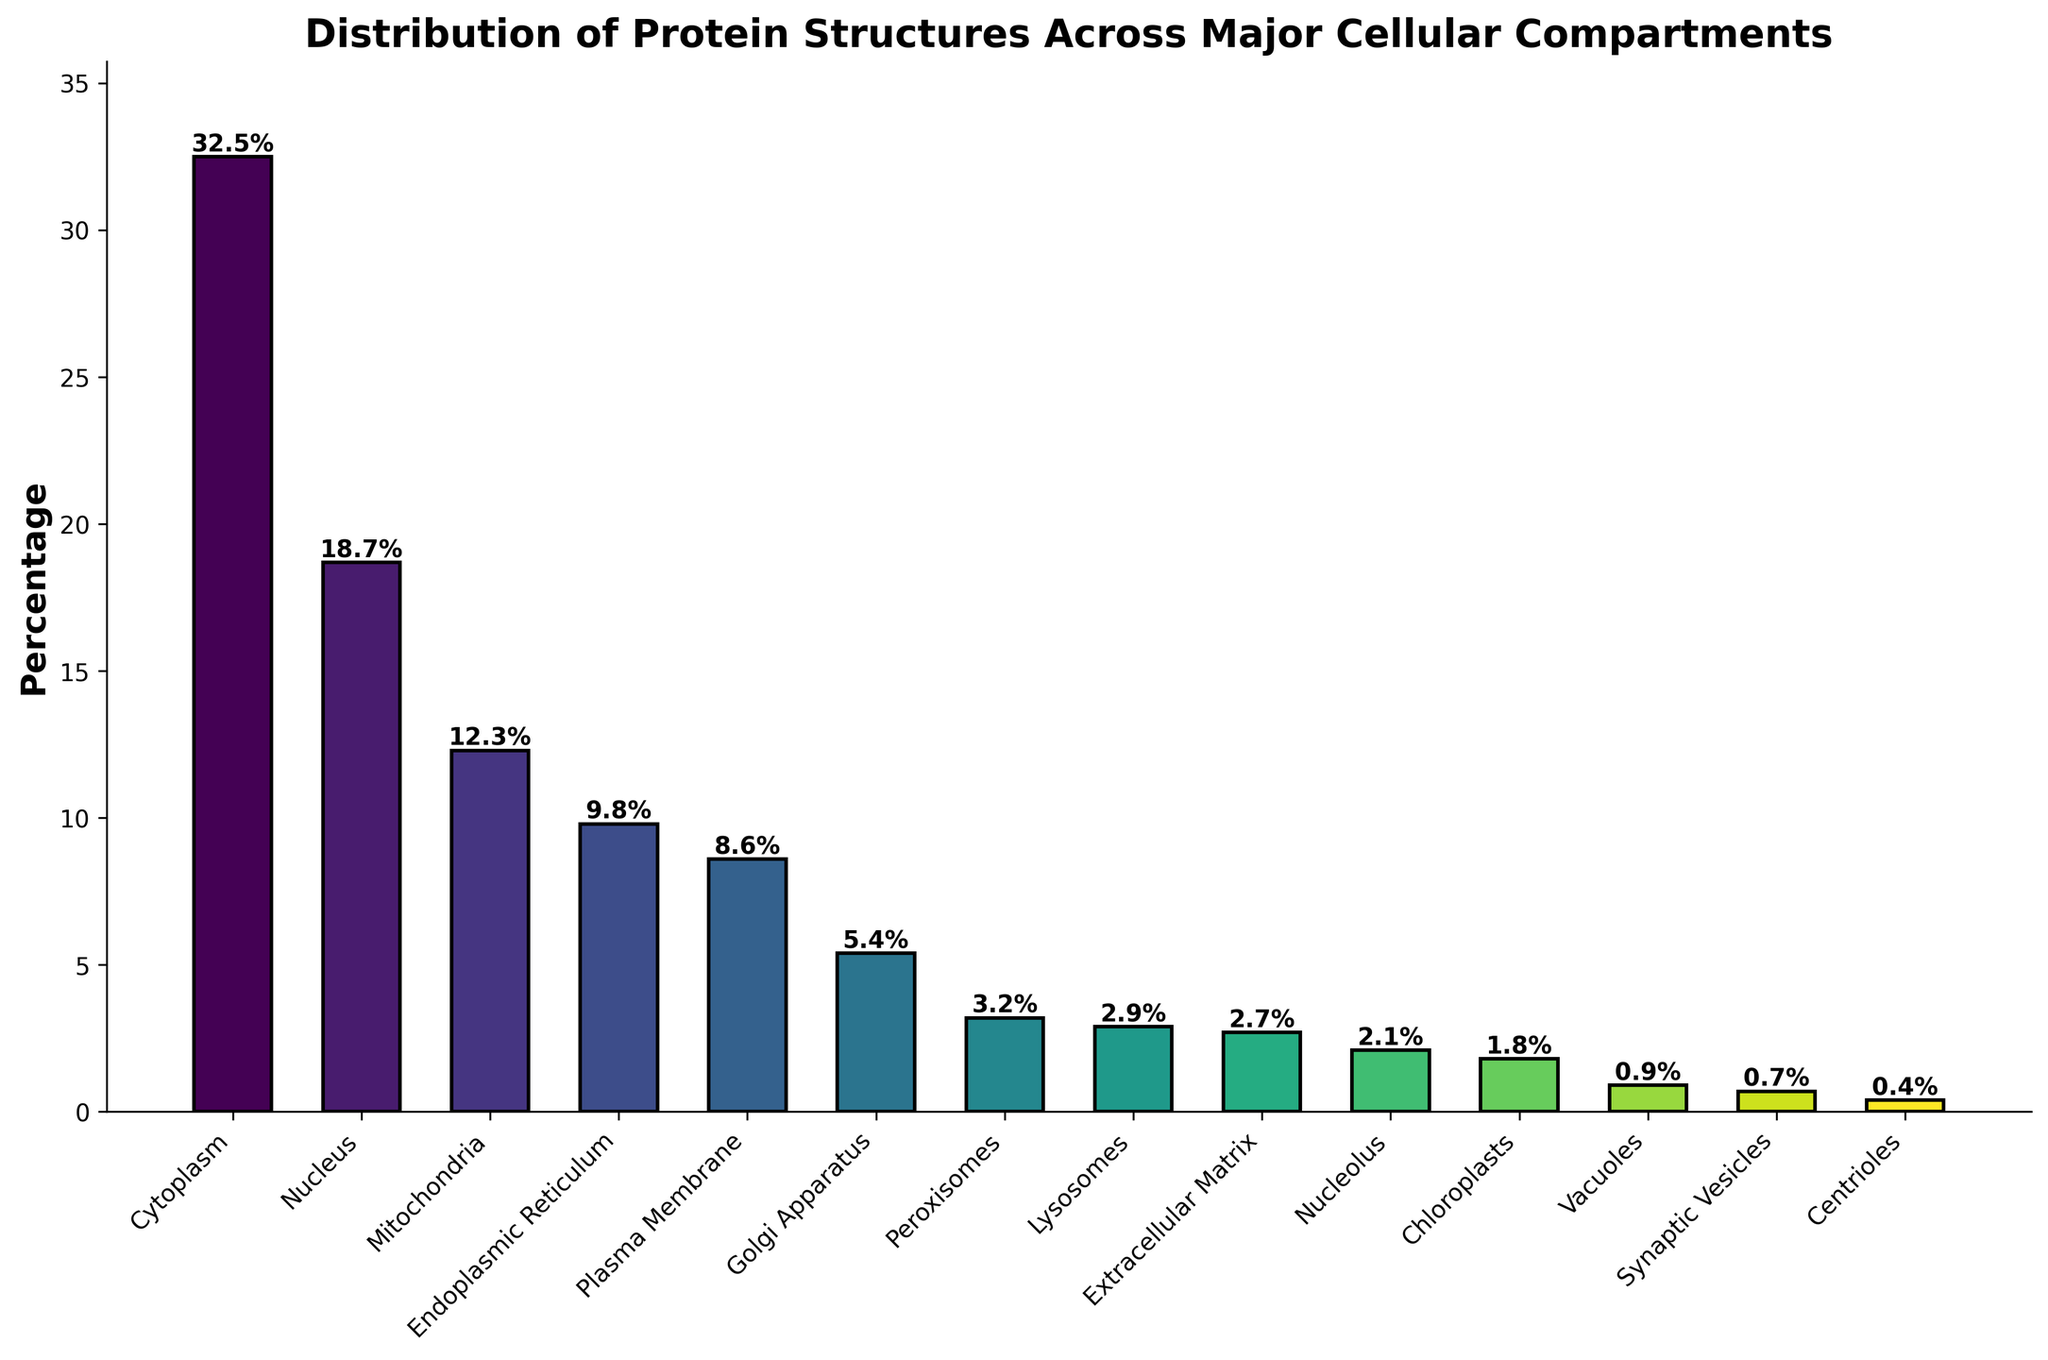Which compartment contains the highest percentage of protein structures? The bar for the Cytoplasm is highest compared to other compartments in the figure. Thus, Cytoplasm has the highest percentage of protein structures.
Answer: Cytoplasm What is the total percentage of protein structures located in the Mitochondria and Endoplasmic Reticulum combined? The percentages for Mitochondria and Endoplasmic Reticulum are 12.3% and 9.8% respectively. Adding these together gives 12.3% + 9.8% = 22.1%.
Answer: 22.1% Which compartment has a lower percentage of protein structures: Golgi Apparatus or Plasma Membrane? By comparing the heights of the bars, the Golgi Apparatus bar is shorter than the Plasma Membrane bar. Hence, Golgi Apparatus has a lower percentage (5.4%) than Plasma Membrane (8.6%).
Answer: Golgi Apparatus How many compartments have a percentage of protein structures greater than 10%? By observing the heights of the bars, the compartments greater than 10% are Cytoplasm, Nucleus, and Mitochondria, totaling 3 compartments.
Answer: 3 What is the difference in the percentage of protein structures between the Nucleus and the Endoplasmic Reticulum? The Nucleus has a percentage of 18.7% and the Endoplasmic Reticulum has 9.8%. The difference is 18.7% - 9.8% = 8.9%.
Answer: 8.9% Which compartments together make up less than 5% of protein structures each? The bars representing Peroxisomes, Lysosomes, Extracellular Matrix, Nucleolus, Chloroplasts, Vacuoles, Synaptic Vesicles, and Centrioles are all under the 5% mark in height, as indicated by the y-axis.
Answer: Peroxisomes, Lysosomes, Extracellular Matrix, Nucleolus, Chloroplasts, Vacuoles, Synaptic Vesicles, Centrioles Among Peroxisomes, Lysosomes, and Extracellular Matrix, which compartment has the largest percentage of protein structures? By observing the bar heights of these three compartments, Peroxisomes has the highest at 3.2%.
Answer: Peroxisomes How does the percentage of protein structures in Nucleus compare to Mitochondria? By comparing the bar heights, the Nucleus bar is taller than the Mitochondria bar. Nucleus has 18.7% and Mitochondria has 12.3%, so the percentage in Nucleus is higher.
Answer: Nucleus is higher What is the average percentage of protein structures in the Nucleolus, Chloroplasts, and Vacuoles? Adding the percentages for these compartments: 2.1% (Nucleolus) + 1.8% (Chloroplasts) + 0.9% (Vacuoles) = 4.8%. Dividing by 3 compartments, 4.8% / 3 = 1.6%.
Answer: 1.6% What is the combined percentage of protein structures for compartments that individually have less than 1%? The compartments below 1% are Vacuoles (0.9%), Synaptic Vesicles (0.7%) and Centrioles (0.4%). Their sum is 0.9% + 0.7% + 0.4% = 2.0%.
Answer: 2.0% 